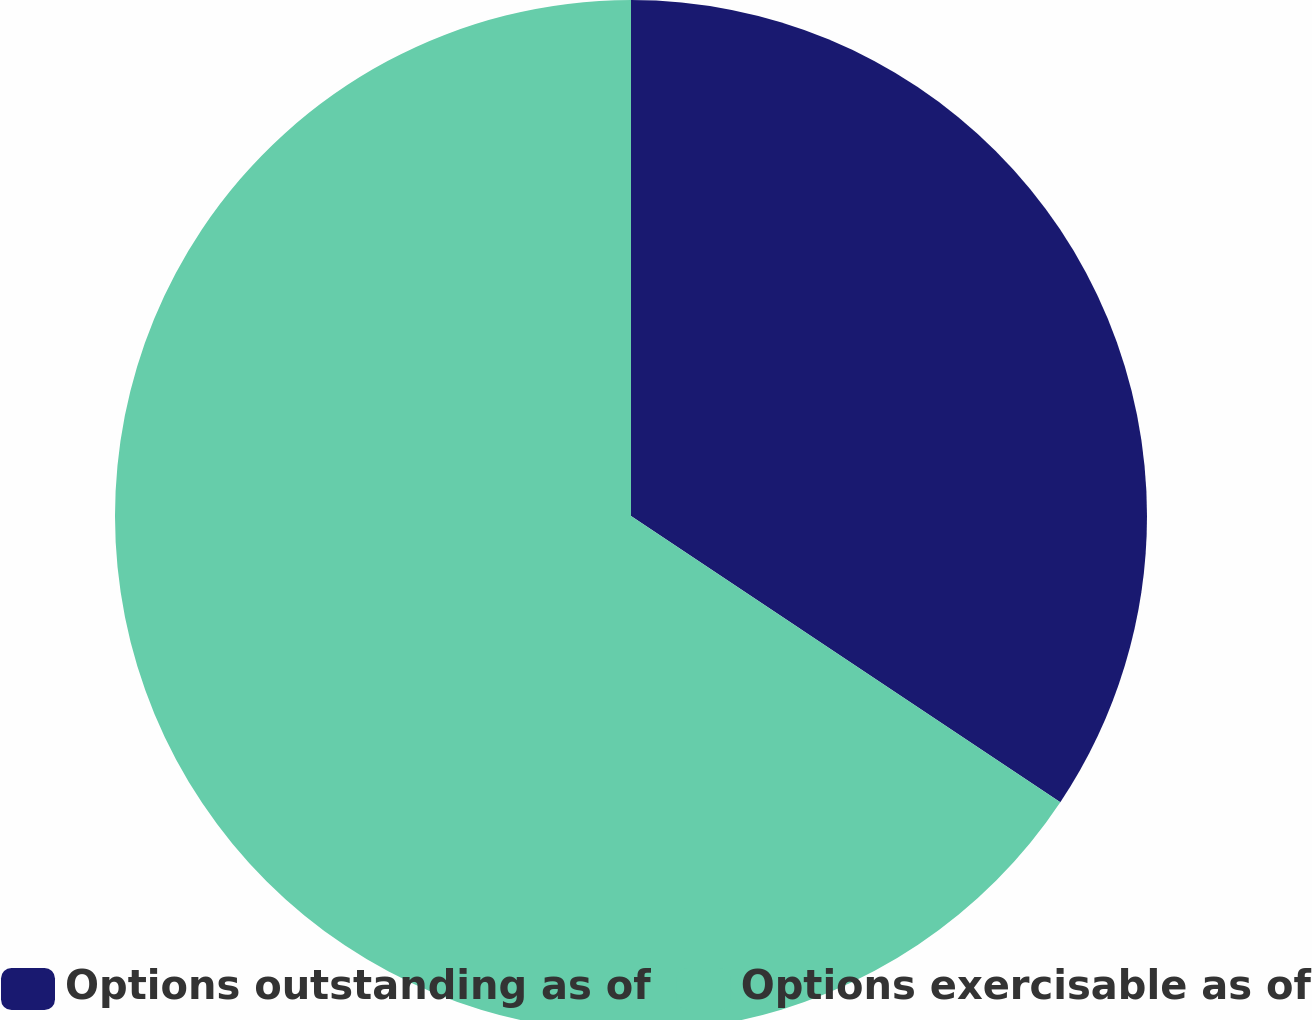Convert chart to OTSL. <chart><loc_0><loc_0><loc_500><loc_500><pie_chart><fcel>Options outstanding as of<fcel>Options exercisable as of<nl><fcel>34.36%<fcel>65.64%<nl></chart> 